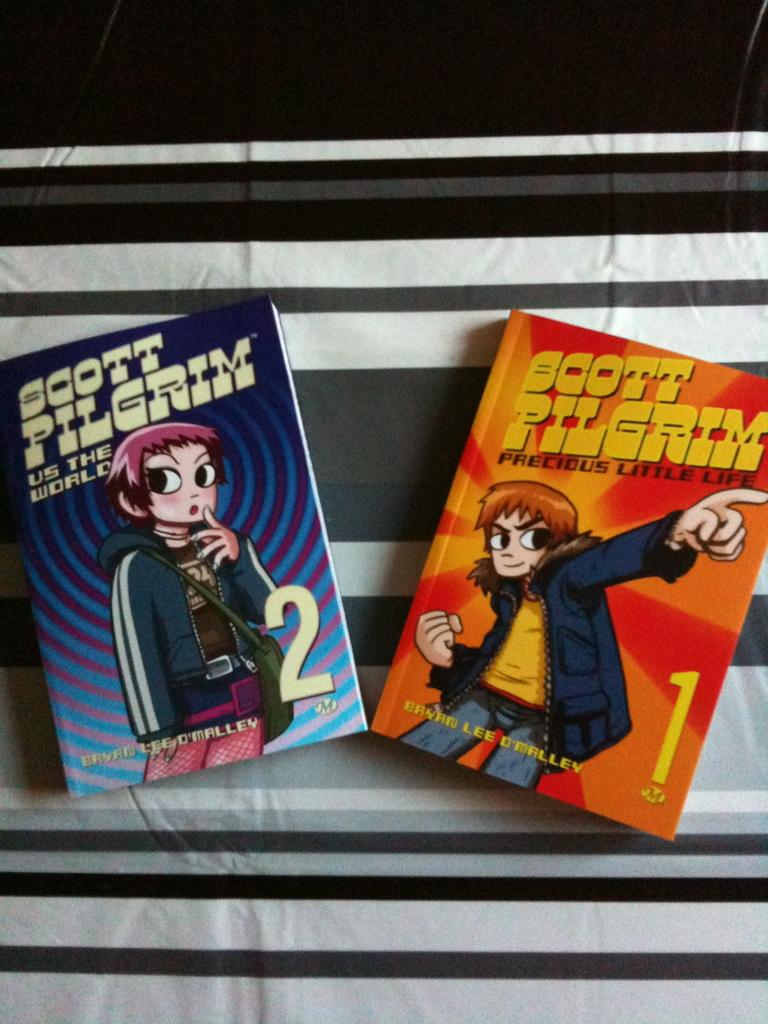Provide a one-sentence caption for the provided image. Two books with the title Scott Pilgrim on them. 